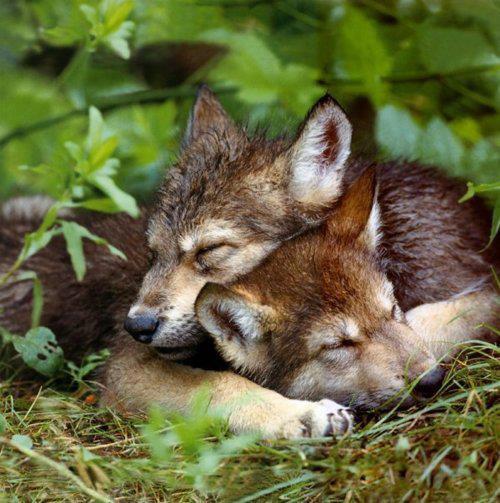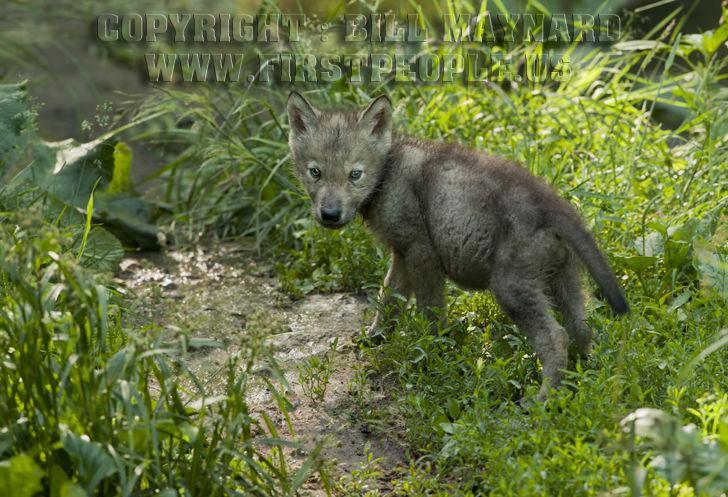The first image is the image on the left, the second image is the image on the right. Assess this claim about the two images: "In the left image, two animals are laying down together.". Correct or not? Answer yes or no. Yes. The first image is the image on the left, the second image is the image on the right. For the images shown, is this caption "One animal is lying their head across the body of another animal." true? Answer yes or no. Yes. 